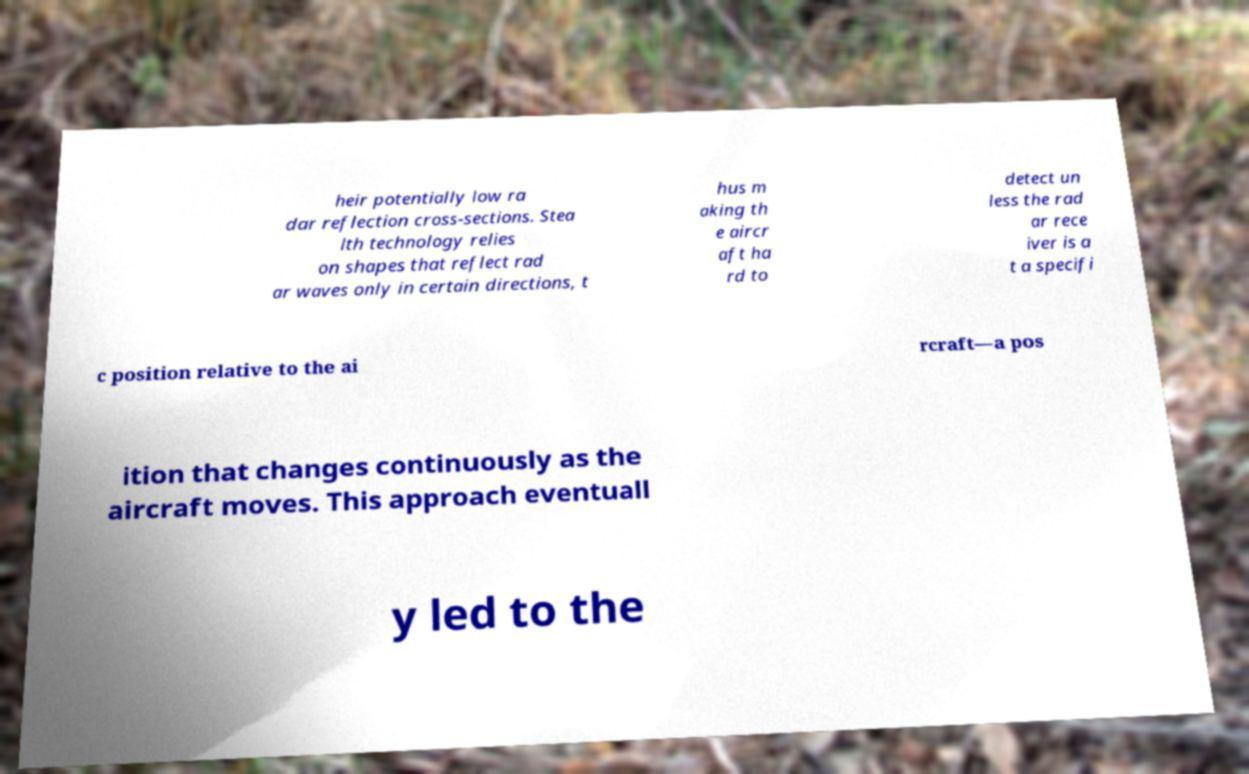There's text embedded in this image that I need extracted. Can you transcribe it verbatim? heir potentially low ra dar reflection cross-sections. Stea lth technology relies on shapes that reflect rad ar waves only in certain directions, t hus m aking th e aircr aft ha rd to detect un less the rad ar rece iver is a t a specifi c position relative to the ai rcraft—a pos ition that changes continuously as the aircraft moves. This approach eventuall y led to the 